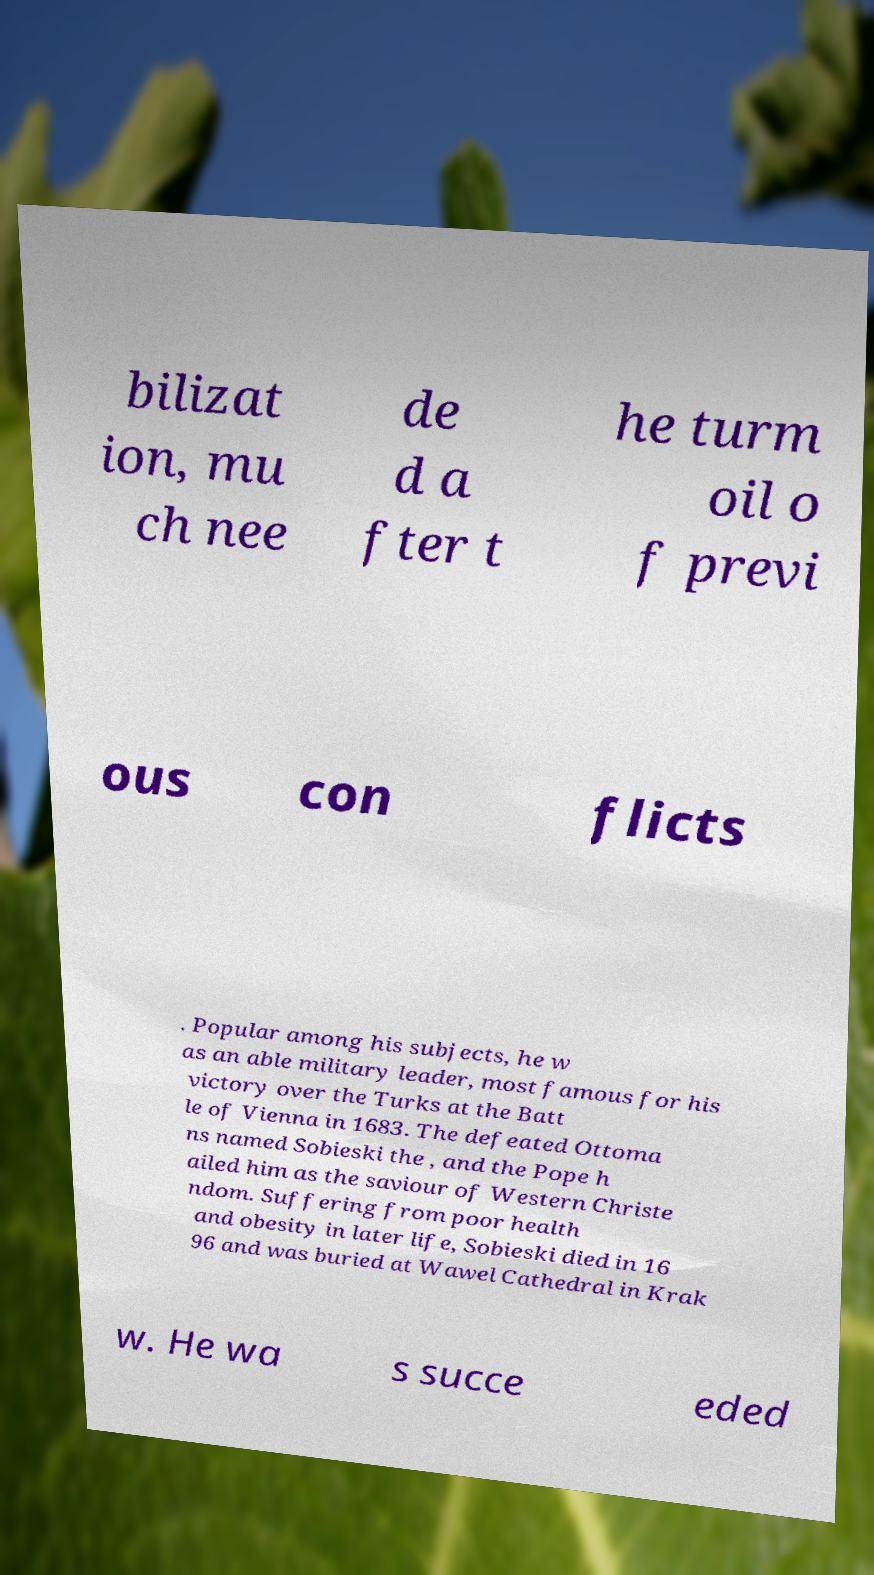Can you read and provide the text displayed in the image?This photo seems to have some interesting text. Can you extract and type it out for me? bilizat ion, mu ch nee de d a fter t he turm oil o f previ ous con flicts . Popular among his subjects, he w as an able military leader, most famous for his victory over the Turks at the Batt le of Vienna in 1683. The defeated Ottoma ns named Sobieski the , and the Pope h ailed him as the saviour of Western Christe ndom. Suffering from poor health and obesity in later life, Sobieski died in 16 96 and was buried at Wawel Cathedral in Krak w. He wa s succe eded 